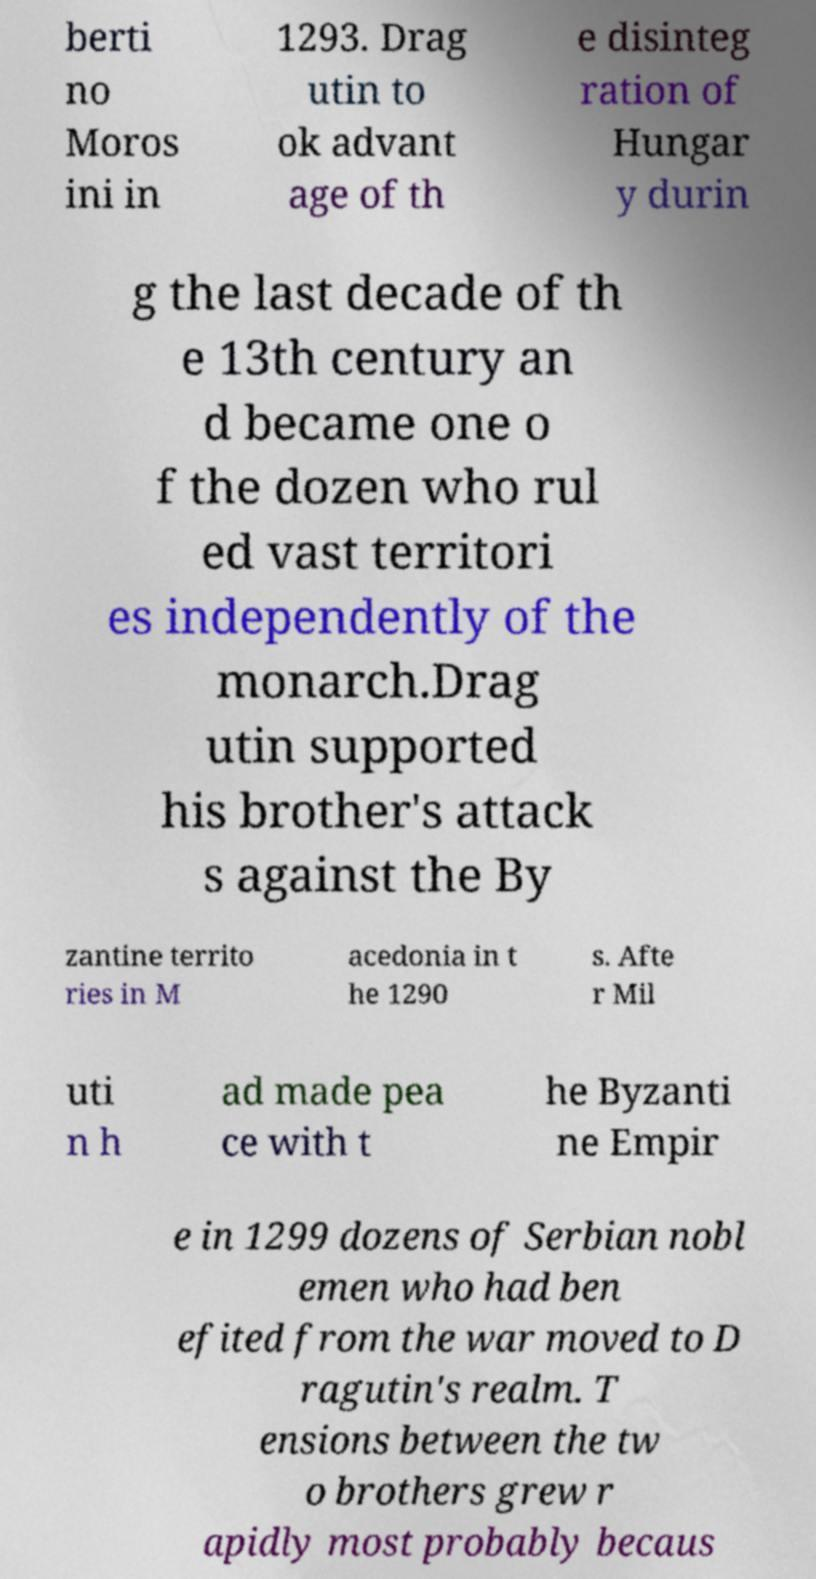Could you assist in decoding the text presented in this image and type it out clearly? berti no Moros ini in 1293. Drag utin to ok advant age of th e disinteg ration of Hungar y durin g the last decade of th e 13th century an d became one o f the dozen who rul ed vast territori es independently of the monarch.Drag utin supported his brother's attack s against the By zantine territo ries in M acedonia in t he 1290 s. Afte r Mil uti n h ad made pea ce with t he Byzanti ne Empir e in 1299 dozens of Serbian nobl emen who had ben efited from the war moved to D ragutin's realm. T ensions between the tw o brothers grew r apidly most probably becaus 